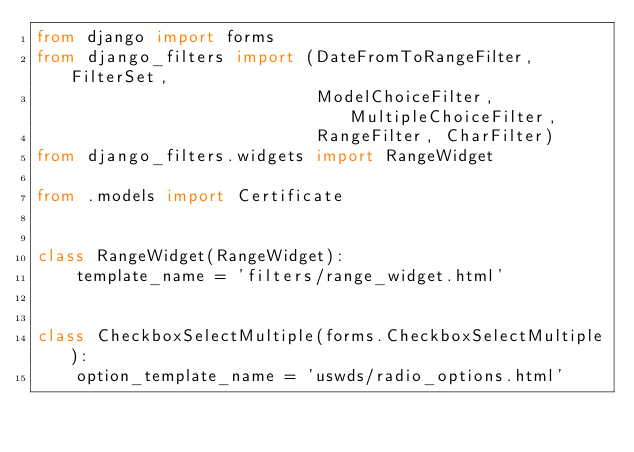Convert code to text. <code><loc_0><loc_0><loc_500><loc_500><_Python_>from django import forms
from django_filters import (DateFromToRangeFilter, FilterSet,
                            ModelChoiceFilter, MultipleChoiceFilter,
                            RangeFilter, CharFilter)
from django_filters.widgets import RangeWidget

from .models import Certificate


class RangeWidget(RangeWidget):
    template_name = 'filters/range_widget.html'


class CheckboxSelectMultiple(forms.CheckboxSelectMultiple):
    option_template_name = 'uswds/radio_options.html'</code> 